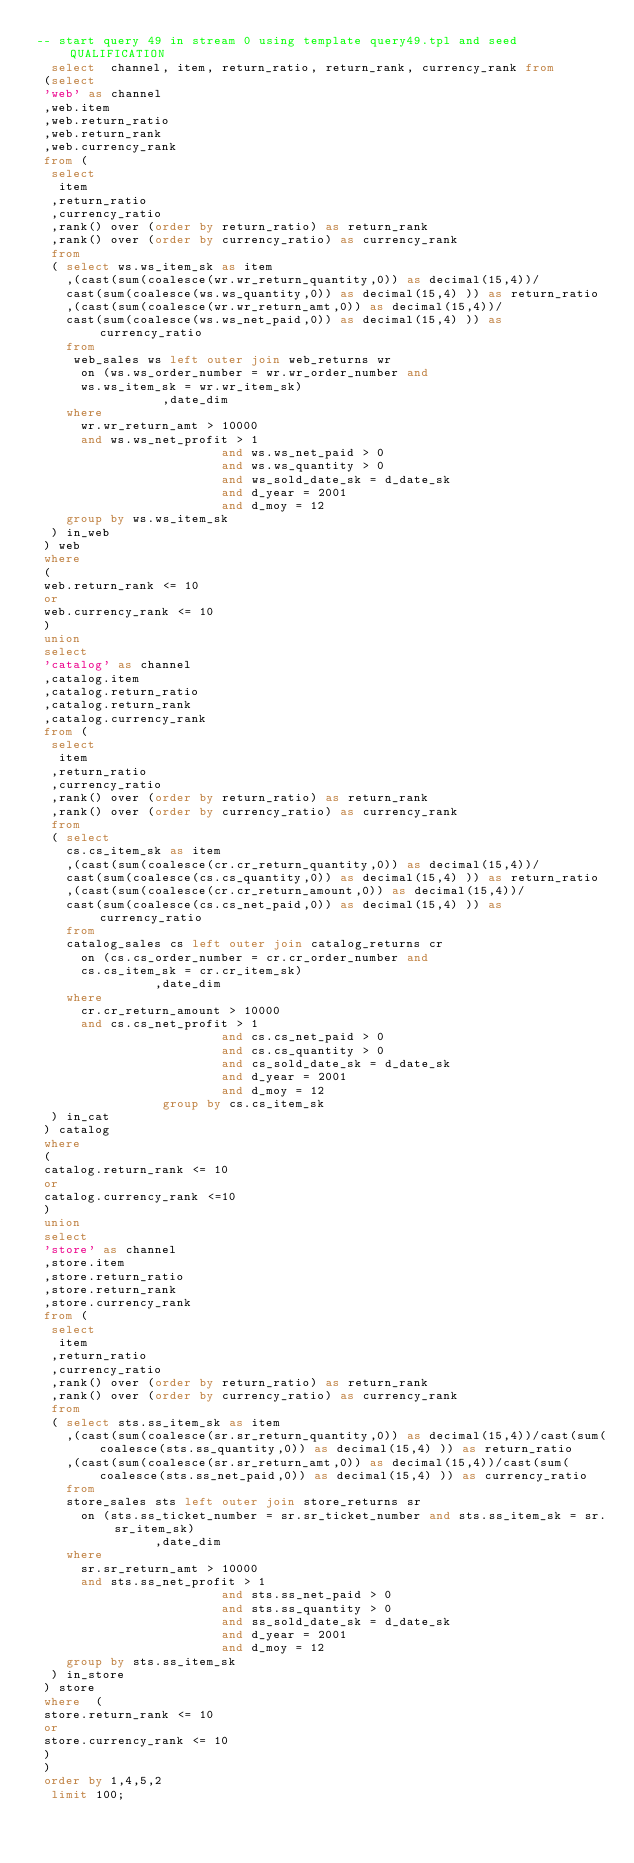<code> <loc_0><loc_0><loc_500><loc_500><_SQL_>-- start query 49 in stream 0 using template query49.tpl and seed QUALIFICATION
  select  channel, item, return_ratio, return_rank, currency_rank from
 (select
 'web' as channel
 ,web.item
 ,web.return_ratio
 ,web.return_rank
 ,web.currency_rank
 from (
 	select 
 	 item
 	,return_ratio
 	,currency_ratio
 	,rank() over (order by return_ratio) as return_rank
 	,rank() over (order by currency_ratio) as currency_rank
 	from
 	(	select ws.ws_item_sk as item
 		,(cast(sum(coalesce(wr.wr_return_quantity,0)) as decimal(15,4))/
 		cast(sum(coalesce(ws.ws_quantity,0)) as decimal(15,4) )) as return_ratio
 		,(cast(sum(coalesce(wr.wr_return_amt,0)) as decimal(15,4))/
 		cast(sum(coalesce(ws.ws_net_paid,0)) as decimal(15,4) )) as currency_ratio
 		from 
 		 web_sales ws left outer join web_returns wr 
 			on (ws.ws_order_number = wr.wr_order_number and 
 			ws.ws_item_sk = wr.wr_item_sk)
                 ,date_dim
 		where 
 			wr.wr_return_amt > 10000 
 			and ws.ws_net_profit > 1
                         and ws.ws_net_paid > 0
                         and ws.ws_quantity > 0
                         and ws_sold_date_sk = d_date_sk
                         and d_year = 2001
                         and d_moy = 12
 		group by ws.ws_item_sk
 	) in_web
 ) web
 where 
 (
 web.return_rank <= 10
 or
 web.currency_rank <= 10
 )
 union
 select 
 'catalog' as channel
 ,catalog.item
 ,catalog.return_ratio
 ,catalog.return_rank
 ,catalog.currency_rank
 from (
 	select 
 	 item
 	,return_ratio
 	,currency_ratio
 	,rank() over (order by return_ratio) as return_rank
 	,rank() over (order by currency_ratio) as currency_rank
 	from
 	(	select 
 		cs.cs_item_sk as item
 		,(cast(sum(coalesce(cr.cr_return_quantity,0)) as decimal(15,4))/
 		cast(sum(coalesce(cs.cs_quantity,0)) as decimal(15,4) )) as return_ratio
 		,(cast(sum(coalesce(cr.cr_return_amount,0)) as decimal(15,4))/
 		cast(sum(coalesce(cs.cs_net_paid,0)) as decimal(15,4) )) as currency_ratio
 		from 
 		catalog_sales cs left outer join catalog_returns cr
 			on (cs.cs_order_number = cr.cr_order_number and 
 			cs.cs_item_sk = cr.cr_item_sk)
                ,date_dim
 		where 
 			cr.cr_return_amount > 10000 
 			and cs.cs_net_profit > 1
                         and cs.cs_net_paid > 0
                         and cs.cs_quantity > 0
                         and cs_sold_date_sk = d_date_sk
                         and d_year = 2001
                         and d_moy = 12
                 group by cs.cs_item_sk
 	) in_cat
 ) catalog
 where 
 (
 catalog.return_rank <= 10
 or
 catalog.currency_rank <=10
 )
 union
 select 
 'store' as channel
 ,store.item
 ,store.return_ratio
 ,store.return_rank
 ,store.currency_rank
 from (
 	select 
 	 item
 	,return_ratio
 	,currency_ratio
 	,rank() over (order by return_ratio) as return_rank
 	,rank() over (order by currency_ratio) as currency_rank
 	from
 	(	select sts.ss_item_sk as item
 		,(cast(sum(coalesce(sr.sr_return_quantity,0)) as decimal(15,4))/cast(sum(coalesce(sts.ss_quantity,0)) as decimal(15,4) )) as return_ratio
 		,(cast(sum(coalesce(sr.sr_return_amt,0)) as decimal(15,4))/cast(sum(coalesce(sts.ss_net_paid,0)) as decimal(15,4) )) as currency_ratio
 		from 
 		store_sales sts left outer join store_returns sr
 			on (sts.ss_ticket_number = sr.sr_ticket_number and sts.ss_item_sk = sr.sr_item_sk)
                ,date_dim
 		where 
 			sr.sr_return_amt > 10000 
 			and sts.ss_net_profit > 1
                         and sts.ss_net_paid > 0 
                         and sts.ss_quantity > 0
                         and ss_sold_date_sk = d_date_sk
                         and d_year = 2001
                         and d_moy = 12
 		group by sts.ss_item_sk
 	) in_store
 ) store
 where  (
 store.return_rank <= 10
 or 
 store.currency_rank <= 10
 )
 )
 order by 1,4,5,2
  limit 100;</code> 